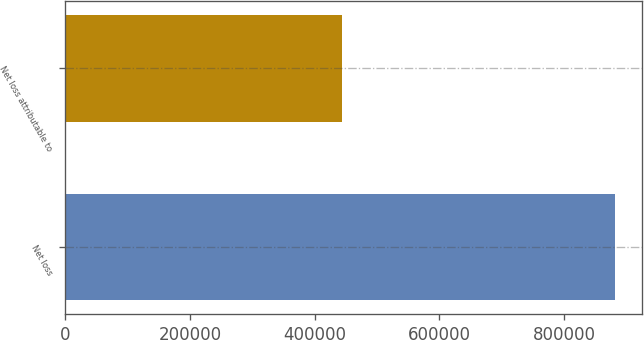<chart> <loc_0><loc_0><loc_500><loc_500><bar_chart><fcel>Net loss<fcel>Net loss attributable to<nl><fcel>881650<fcel>444217<nl></chart> 